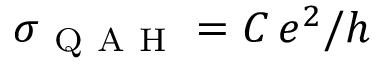<formula> <loc_0><loc_0><loc_500><loc_500>\sigma _ { Q A H } = C \, e ^ { 2 } / h</formula> 